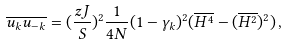<formula> <loc_0><loc_0><loc_500><loc_500>\overline { u _ { k } u _ { - k } } = ( \frac { z J } { S } ) ^ { 2 } \frac { 1 } { 4 N } ( 1 - \gamma _ { k } ) ^ { 2 } ( \overline { H ^ { 4 } } - ( \overline { H ^ { 2 } } ) ^ { 2 } ) \, ,</formula> 